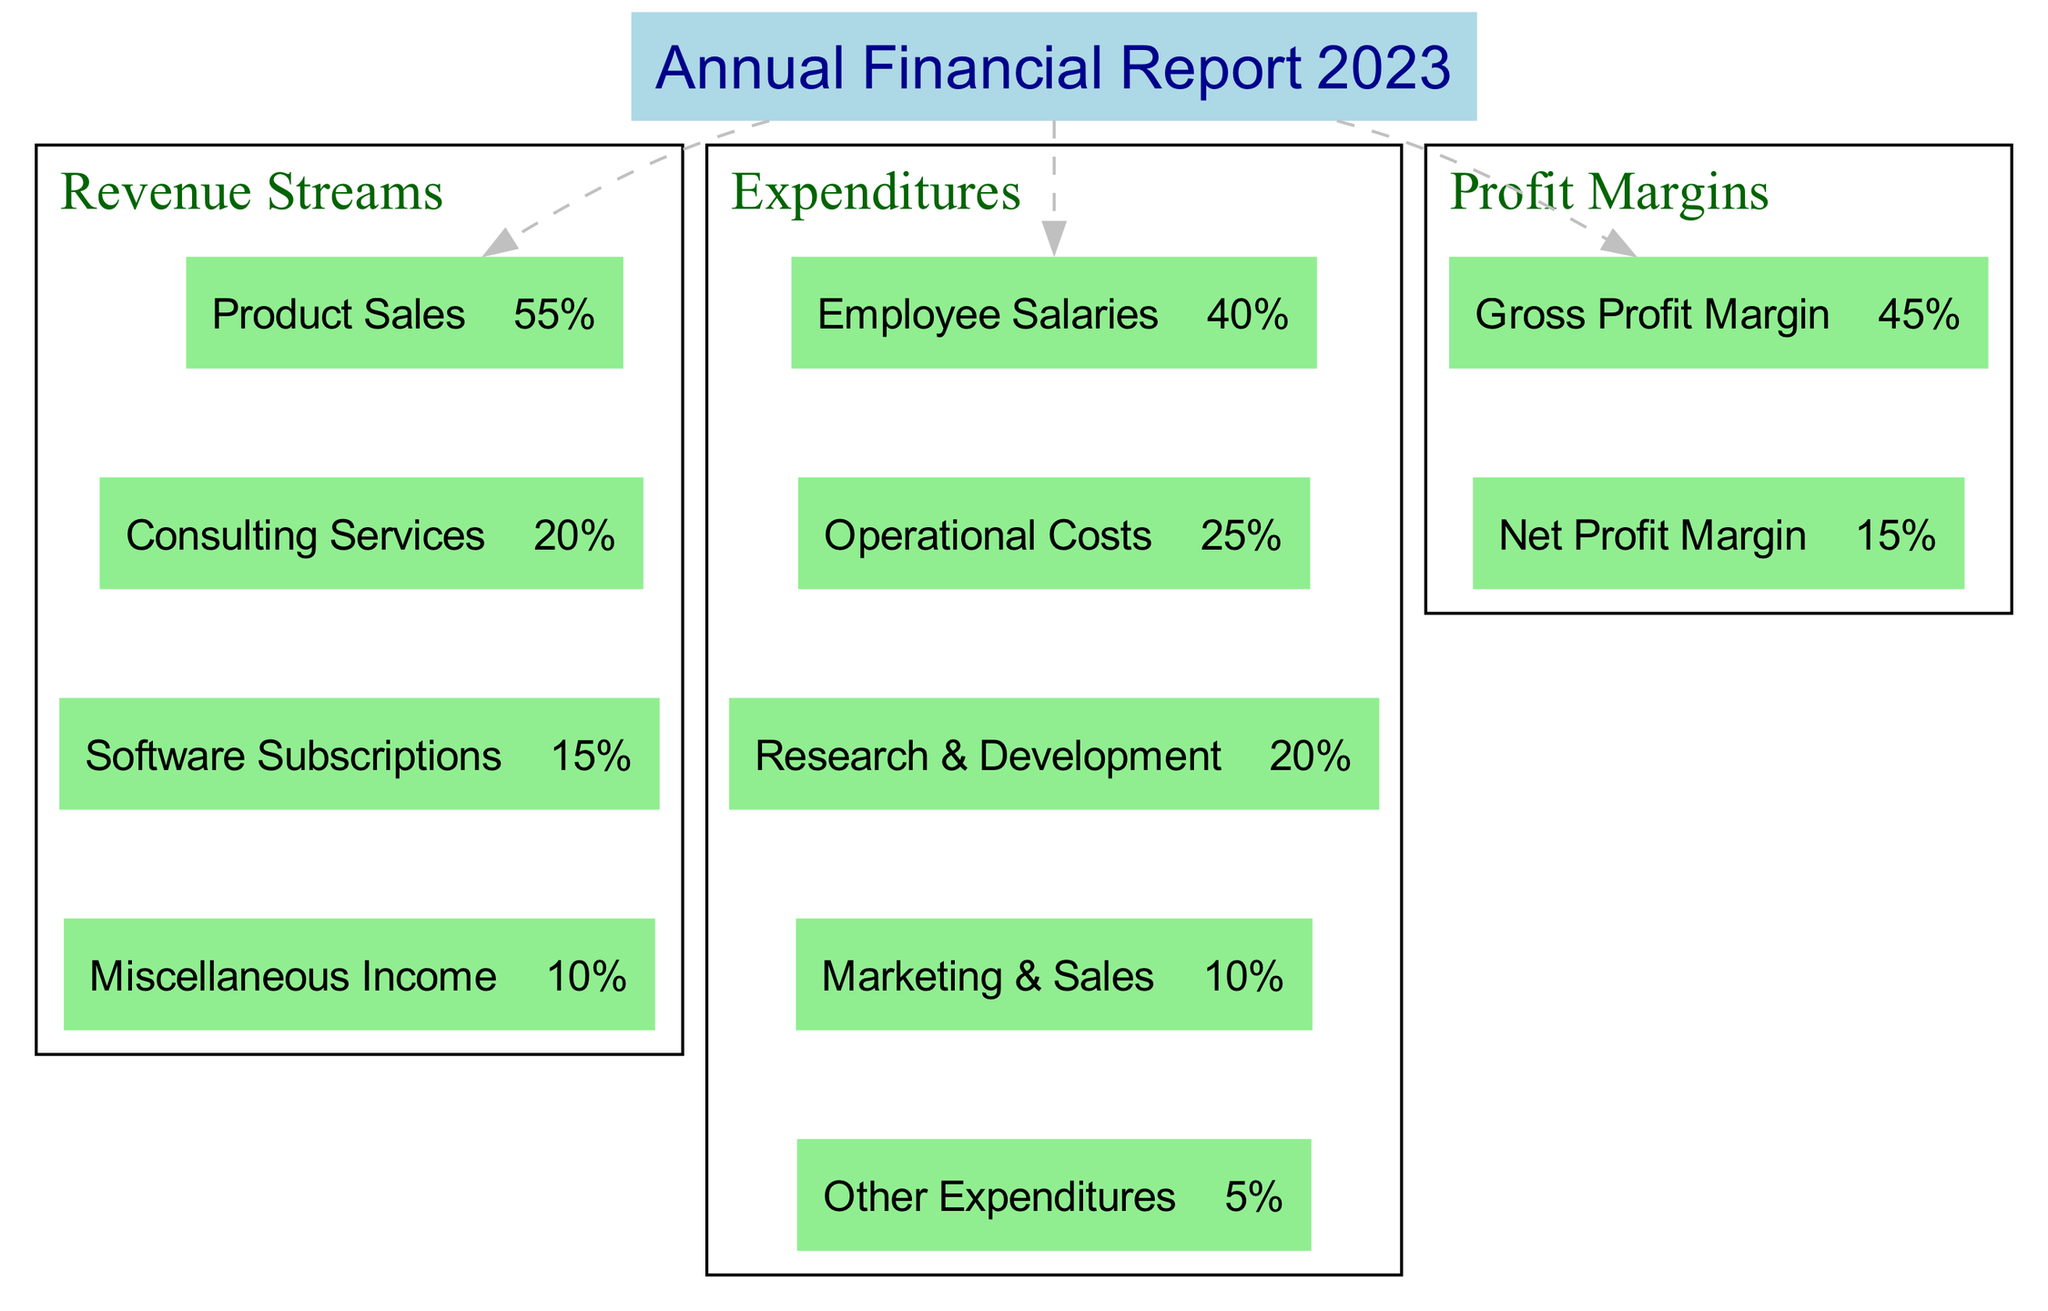What is the percentage of revenue from Product Sales? The diagram shows that the revenue stream labeled "Product Sales" has a percentage value listed alongside it. Looking at the Revenue Streams section, we can find that Product Sales accounts for 55% of the total revenue.
Answer: 55% What is the total percentage of Consulting Services and Software Subscriptions? To find the combined percentage for Consulting Services and Software Subscriptions, we need to add their respective percentages. Consulting Services accounts for 20%, and Software Subscriptions account for 15%. Therefore, 20% + 15% equals 35%.
Answer: 35% Which expenditure category has the smallest percentage? The Expenditures section has multiple categories listed. By reviewing each category's percentage, we find that "Other Expenditures" has the smallest percentage, which is 5%.
Answer: Other Expenditures What is the Gross Profit Margin percentage? The Profit Margins subsection provides specific margin values. According to the diagram, the Gross Profit Margin is stated as 45%.
Answer: 45% If the total revenue is $1,000,000, what would be the value contributed by Software Subscriptions? To determine the revenue from Software Subscriptions, the percentage contribution (15%) should be taken from the total revenue of $1,000,000. Calculating this gives us 15% of $1,000,000, which amounts to $150,000.
Answer: $150,000 What is the total percentage of all expenditure categories combined? To find the total percentage of all expenditures, we need to add the percentages of each category in the Expenditures section. This includes: Employee Salaries (40%), Operational Costs (25%), R&D (20%), Marketing & Sales (10%), and Other Expenditures (5%). Adding these gives us a total of 100%.
Answer: 100% Which section has a higher individual total, Revenue Streams or Expenditures? The diagram presents the total percentages for both sections. However, Revenue Streams account for various income sources totaling 100%, whereas Expenditures also total 100%. Thus, they are equal when considering total percentages for their respective sections.
Answer: Equal What is the percentage difference between Gross Profit Margin and Net Profit Margin? The difference can be calculated by subtracting the Net Profit Margin (15%) from the Gross Profit Margin (45%). Therefore, 45% - 15% calculates to a difference of 30%.
Answer: 30% 